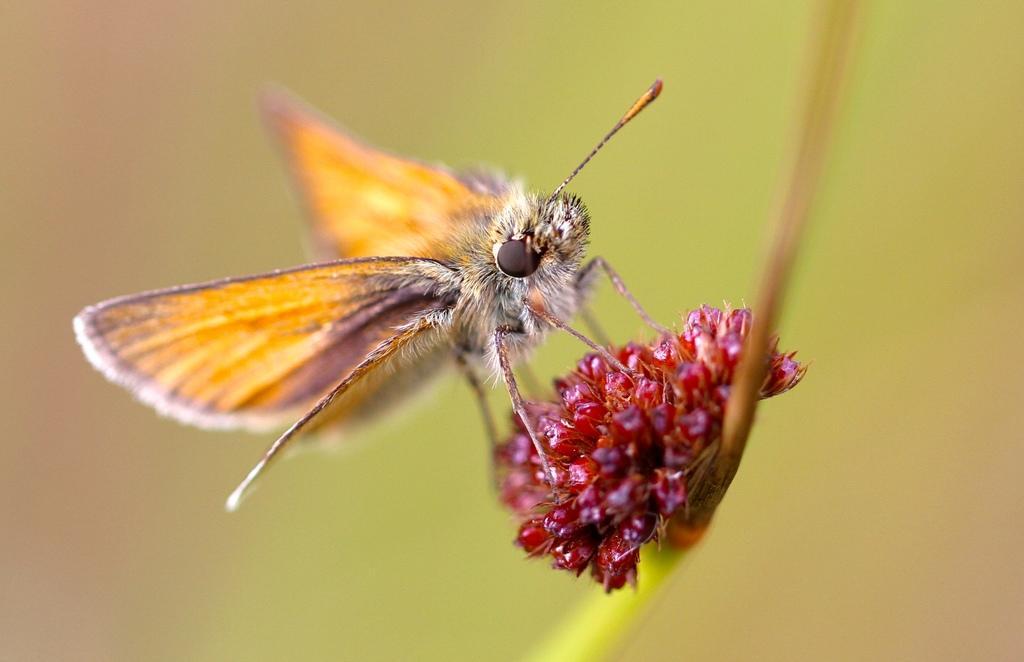How would you summarize this image in a sentence or two? In this image we can see an insect on a flower. The background is blurred. 